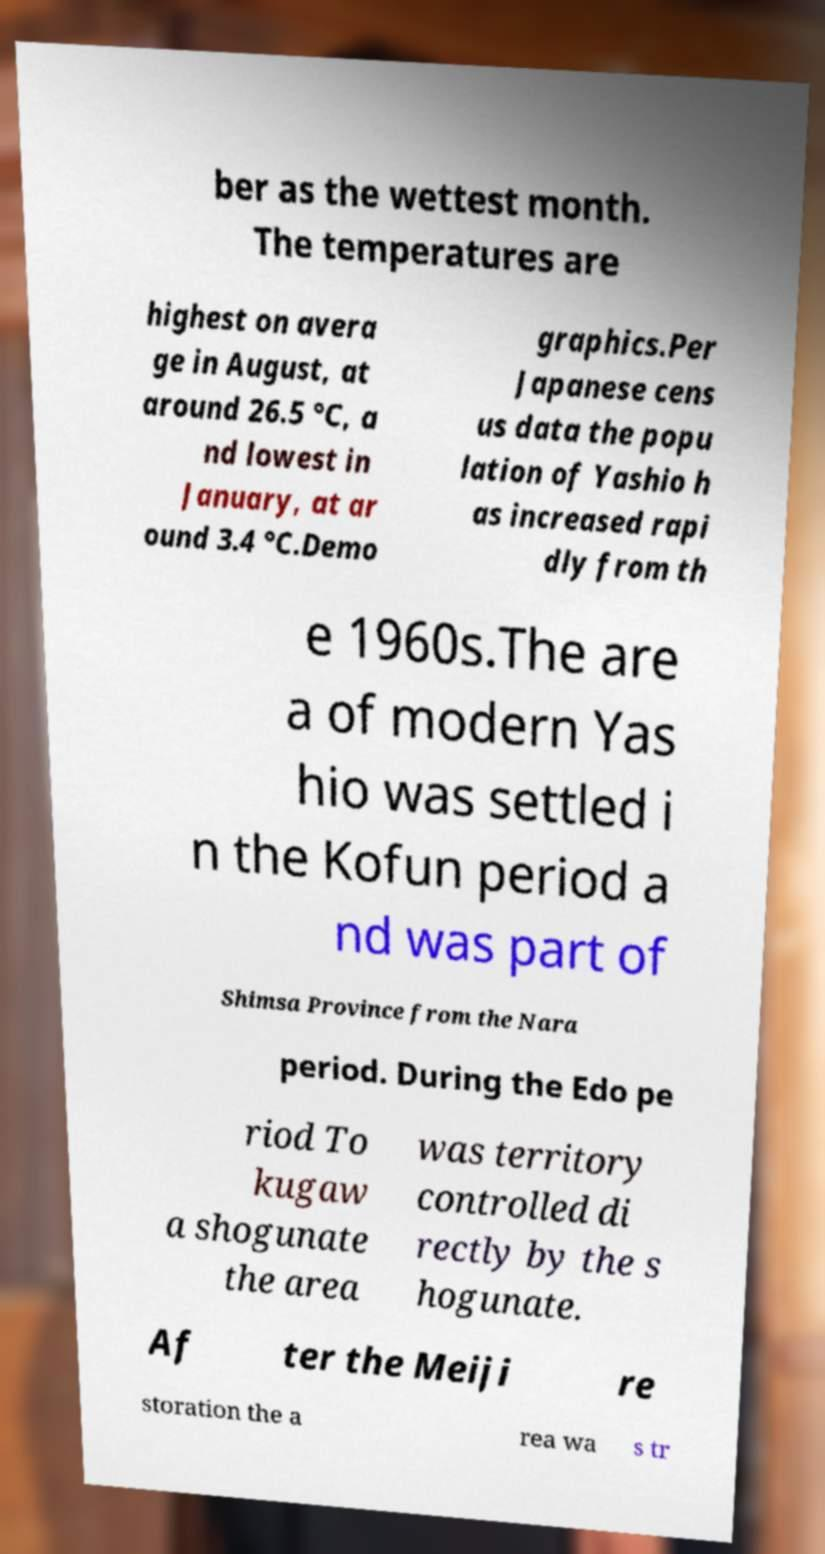Please identify and transcribe the text found in this image. ber as the wettest month. The temperatures are highest on avera ge in August, at around 26.5 °C, a nd lowest in January, at ar ound 3.4 °C.Demo graphics.Per Japanese cens us data the popu lation of Yashio h as increased rapi dly from th e 1960s.The are a of modern Yas hio was settled i n the Kofun period a nd was part of Shimsa Province from the Nara period. During the Edo pe riod To kugaw a shogunate the area was territory controlled di rectly by the s hogunate. Af ter the Meiji re storation the a rea wa s tr 